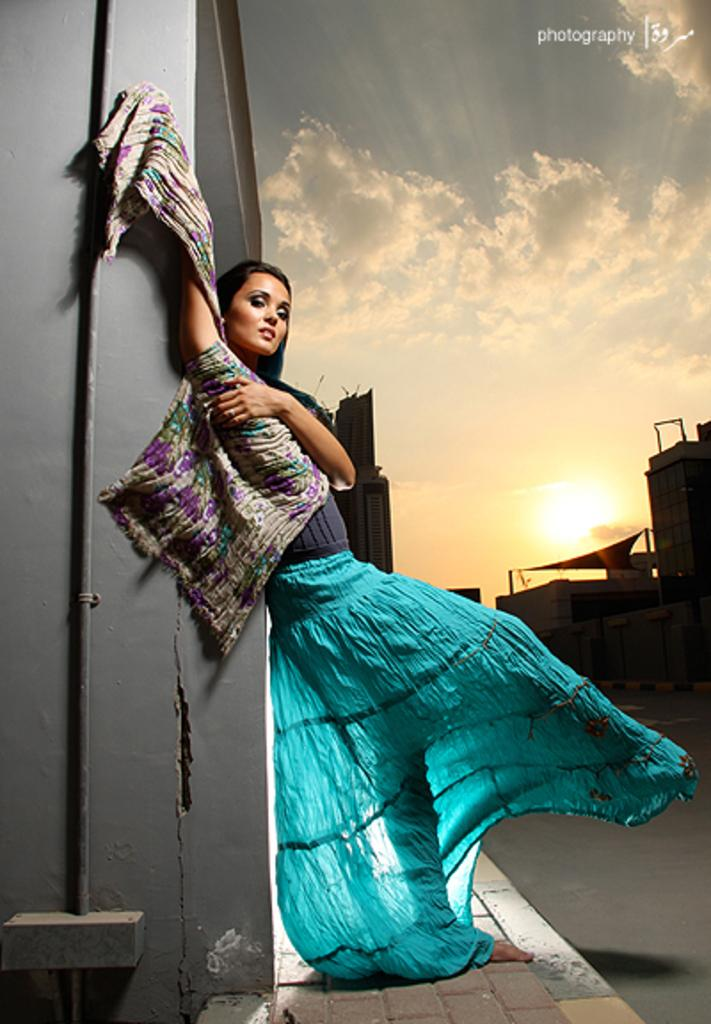What is the main subject of the image? There is a woman standing in the image. Can you describe the woman's attire? The woman is wearing clothes. What type of surface can be seen beneath the woman's feet? There is a footpath in the image. What type of structures are visible in the background? There are buildings in the image. How would you describe the weather conditions in the image? The sky is cloudy, but the sun is also visible in the image. What type of knowledge is the woman imparting to the wound in the image? There is no wound present in the image, and the woman is not imparting any knowledge. 